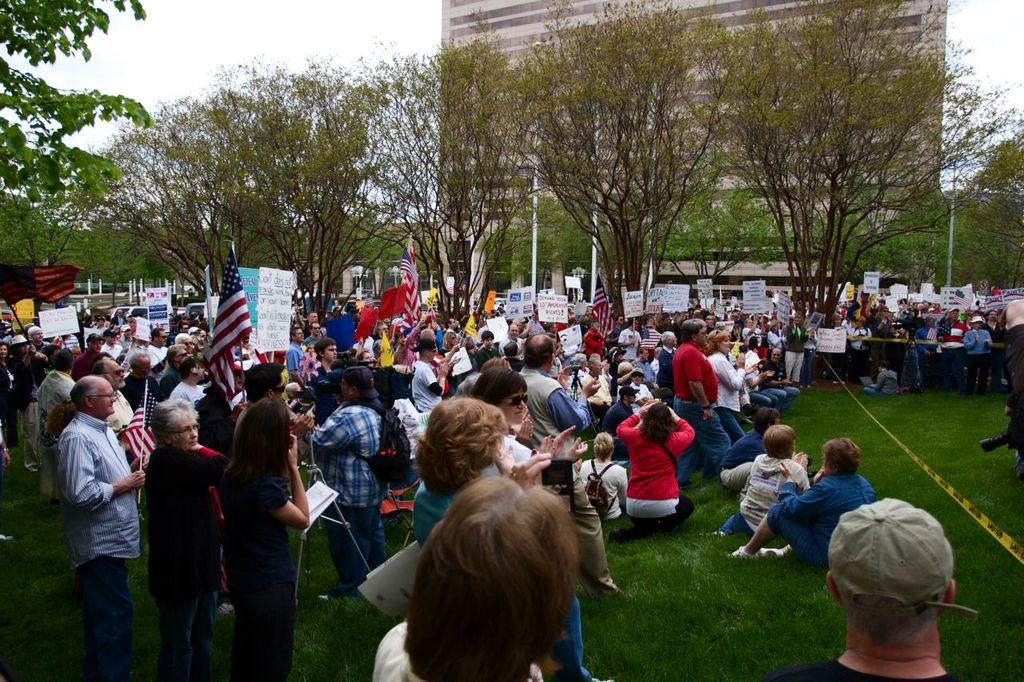What are the people in the image holding? The people in the image are holding boards with text. What can be seen in the background of the image? There are trees and a building in the background of the image. What type of coast can be seen in the image? There is no coast visible in the image; it features people holding boards with text and a background with trees and a building. 